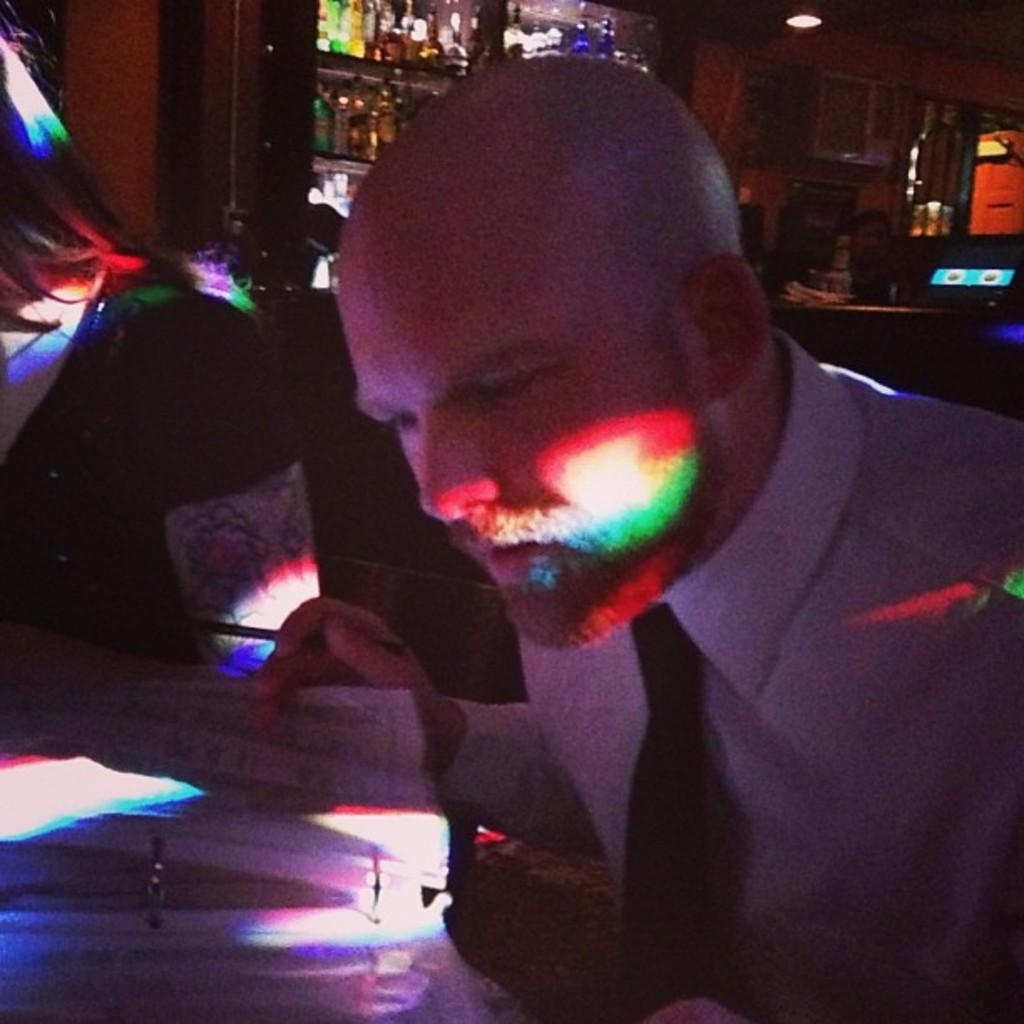Who is the main subject in the image? There is a man in the middle of the image. What is the man doing in the image? The man is looking at papers. What type of clothing is the man wearing? The man is wearing a tie and a shirt. What can be seen in the background of the image? There are bottles in the background of the image. What is the source of light in the image? There is a light at the top of the image. What type of oil is being used in the image? There is no oil present in the image. What religious symbols can be seen in the image? There are no religious symbols present in the image. 